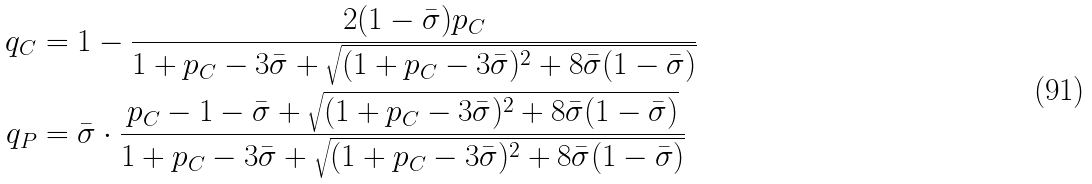<formula> <loc_0><loc_0><loc_500><loc_500>q _ { C } & = 1 - \frac { 2 ( 1 - \bar { \sigma } ) p _ { C } } { 1 + p _ { C } - 3 \bar { \sigma } + \sqrt { ( 1 + p _ { C } - 3 \bar { \sigma } ) ^ { 2 } + 8 \bar { \sigma } ( 1 - \bar { \sigma } ) } } \\ q _ { P } & = \bar { \sigma } \cdot \frac { p _ { C } - 1 - \bar { \sigma } + \sqrt { ( 1 + p _ { C } - 3 \bar { \sigma } ) ^ { 2 } + 8 \bar { \sigma } ( 1 - \bar { \sigma } ) } } { 1 + p _ { C } - 3 \bar { \sigma } + \sqrt { ( 1 + p _ { C } - 3 \bar { \sigma } ) ^ { 2 } + 8 \bar { \sigma } ( 1 - \bar { \sigma } ) } }</formula> 